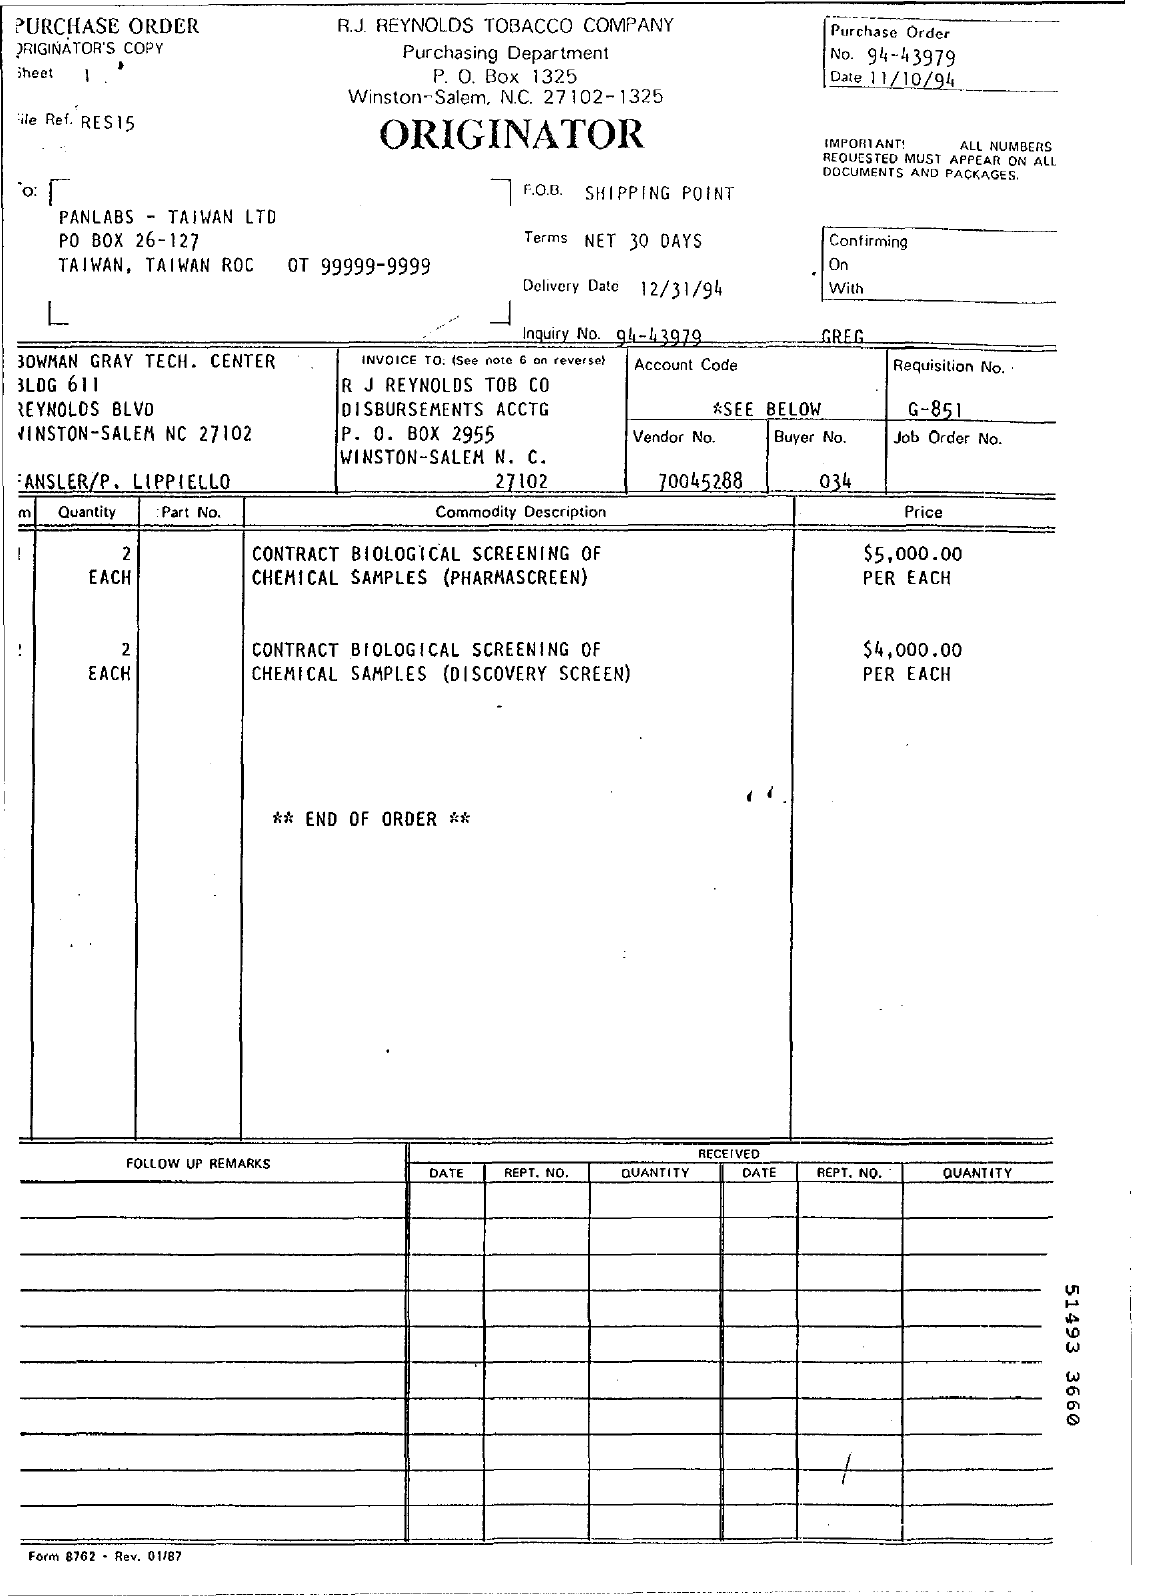What is the date mentioned in the top of the document ?
Your answer should be very brief. 11/10/94. What is the Purchase order number ?
Make the answer very short. 94-43979. What is the Vendor Number ?
Provide a succinct answer. 70045288. What is the Buyer Number ?
Keep it short and to the point. 034. What is the Delivery Date ?
Give a very brief answer. 12/31/94. 